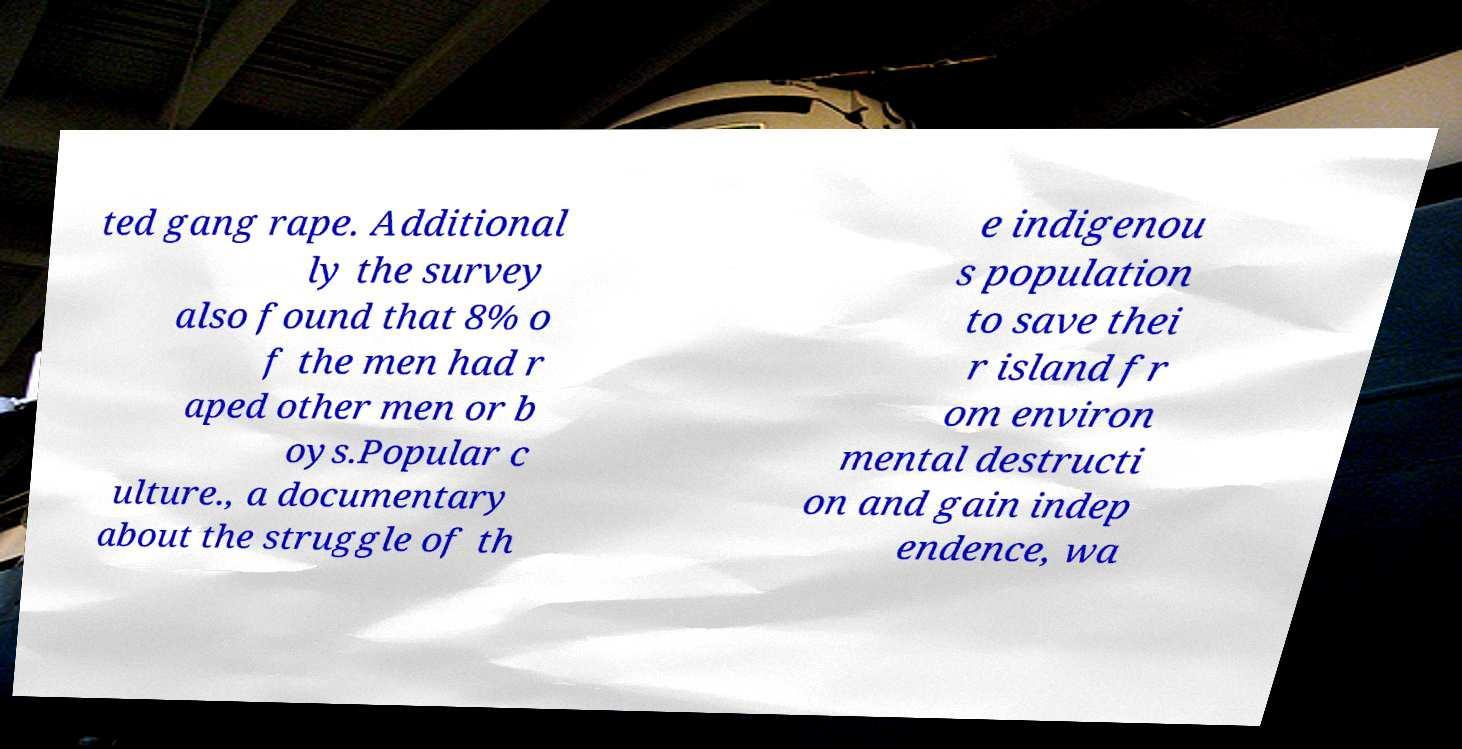Could you extract and type out the text from this image? ted gang rape. Additional ly the survey also found that 8% o f the men had r aped other men or b oys.Popular c ulture., a documentary about the struggle of th e indigenou s population to save thei r island fr om environ mental destructi on and gain indep endence, wa 